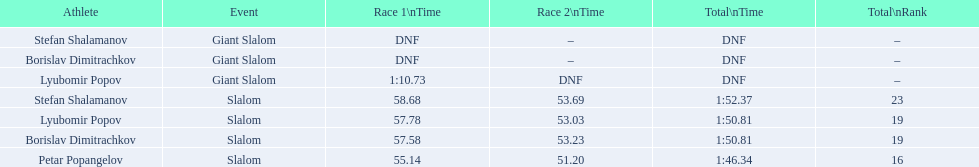In which contest does the giant slalom take place? Giant Slalom, Giant Slalom, Giant Slalom. Who can be identified as lyubomir popov? Lyubomir Popov. What is the time for the initial race? 1:10.73. 